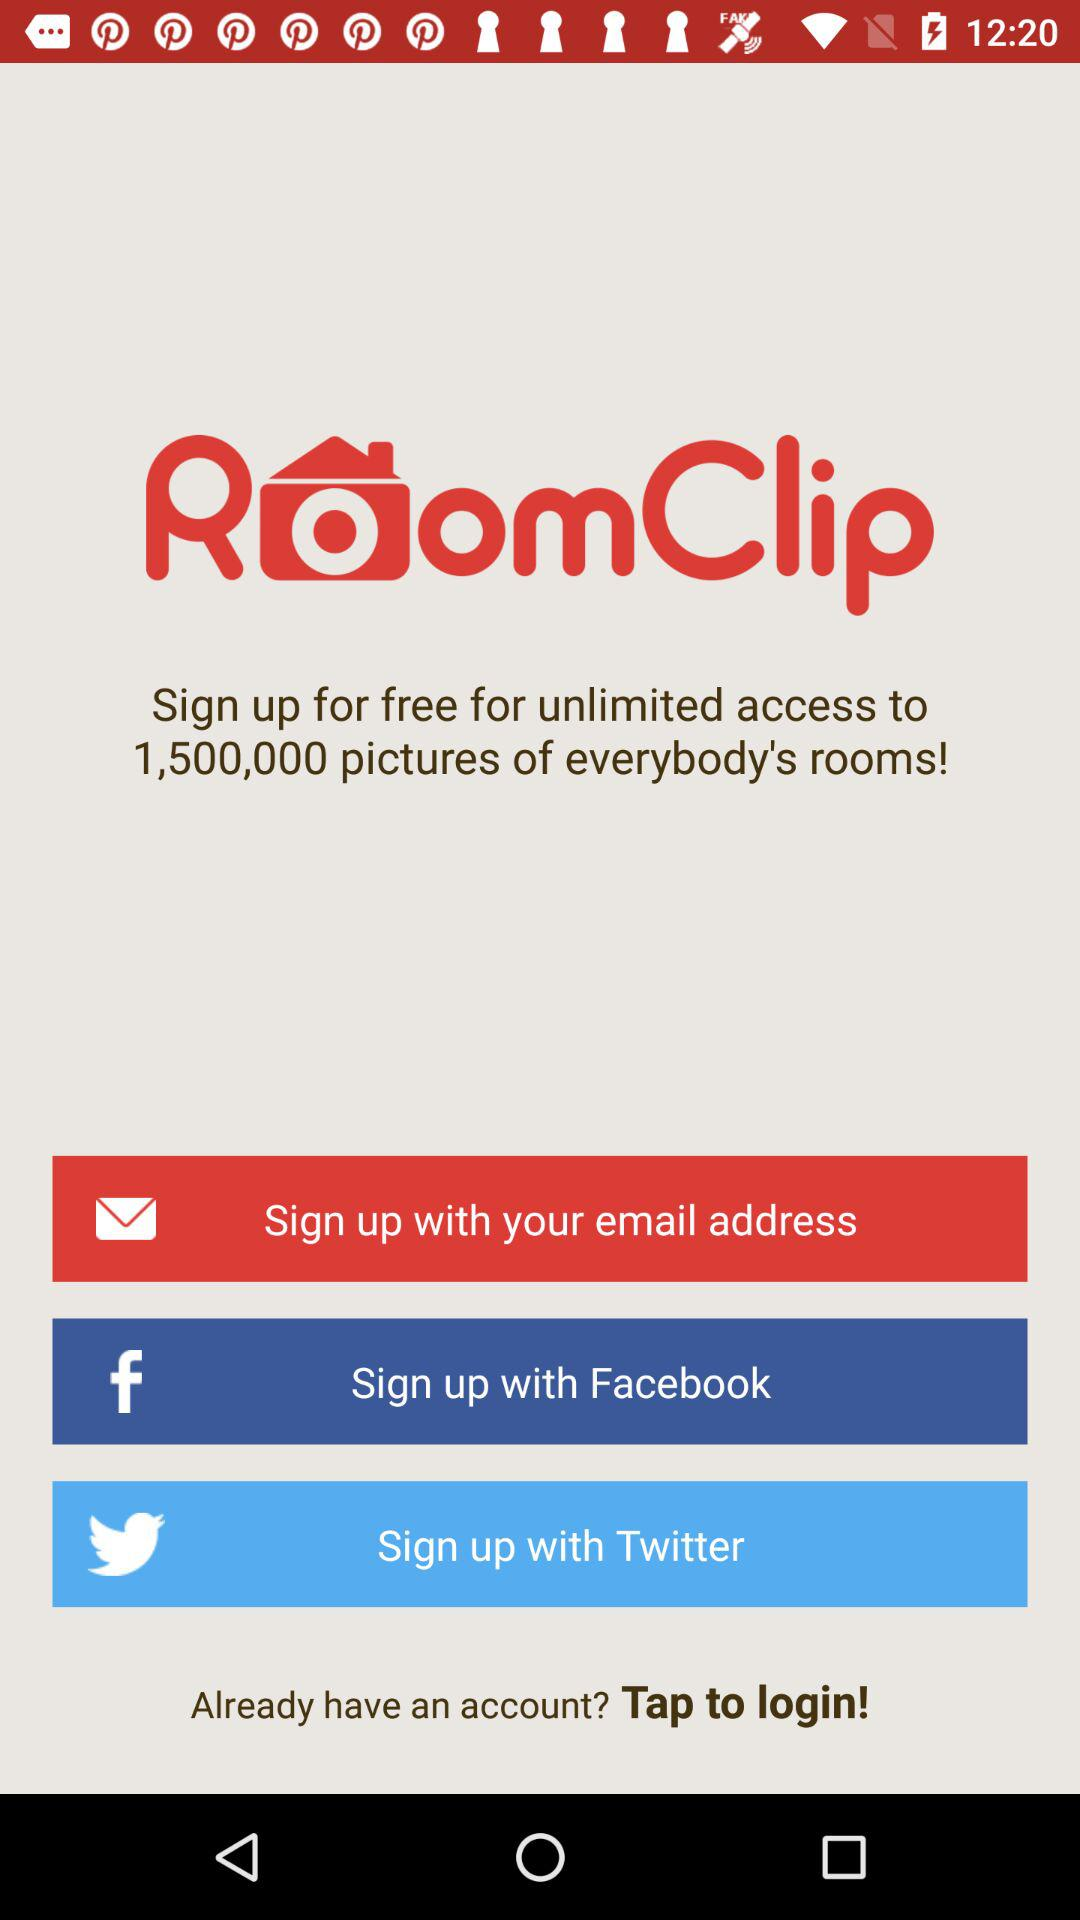How many pictures of other people's rooms can I access if I sign up for free?
Answer the question using a single word or phrase. 1,500,000 